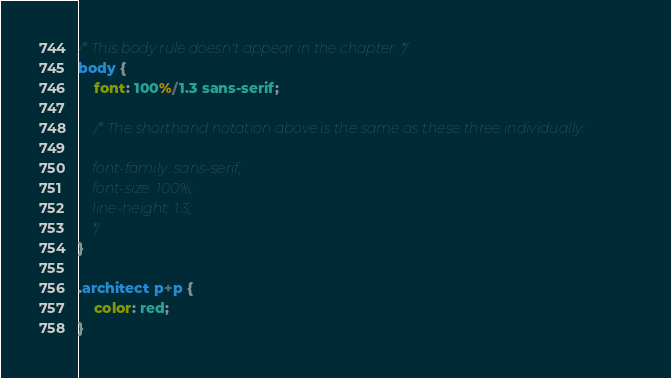Convert code to text. <code><loc_0><loc_0><loc_500><loc_500><_CSS_>/* This body rule doesn't appear in the chapter. */
body {
	font: 100%/1.3 sans-serif;
	
	/* The shorthand notation above is the same as these three individually:
	
	font-family: sans-serif;
	font-size: 100%;
	line-height: 1.3;
	*/
}

.architect p+p {
	color: red;
}


</code> 